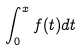Convert formula to latex. <formula><loc_0><loc_0><loc_500><loc_500>\int _ { 0 } ^ { x } f ( t ) d t</formula> 